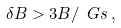<formula> <loc_0><loc_0><loc_500><loc_500>\delta B > 3 B / \ G s \, ,</formula> 